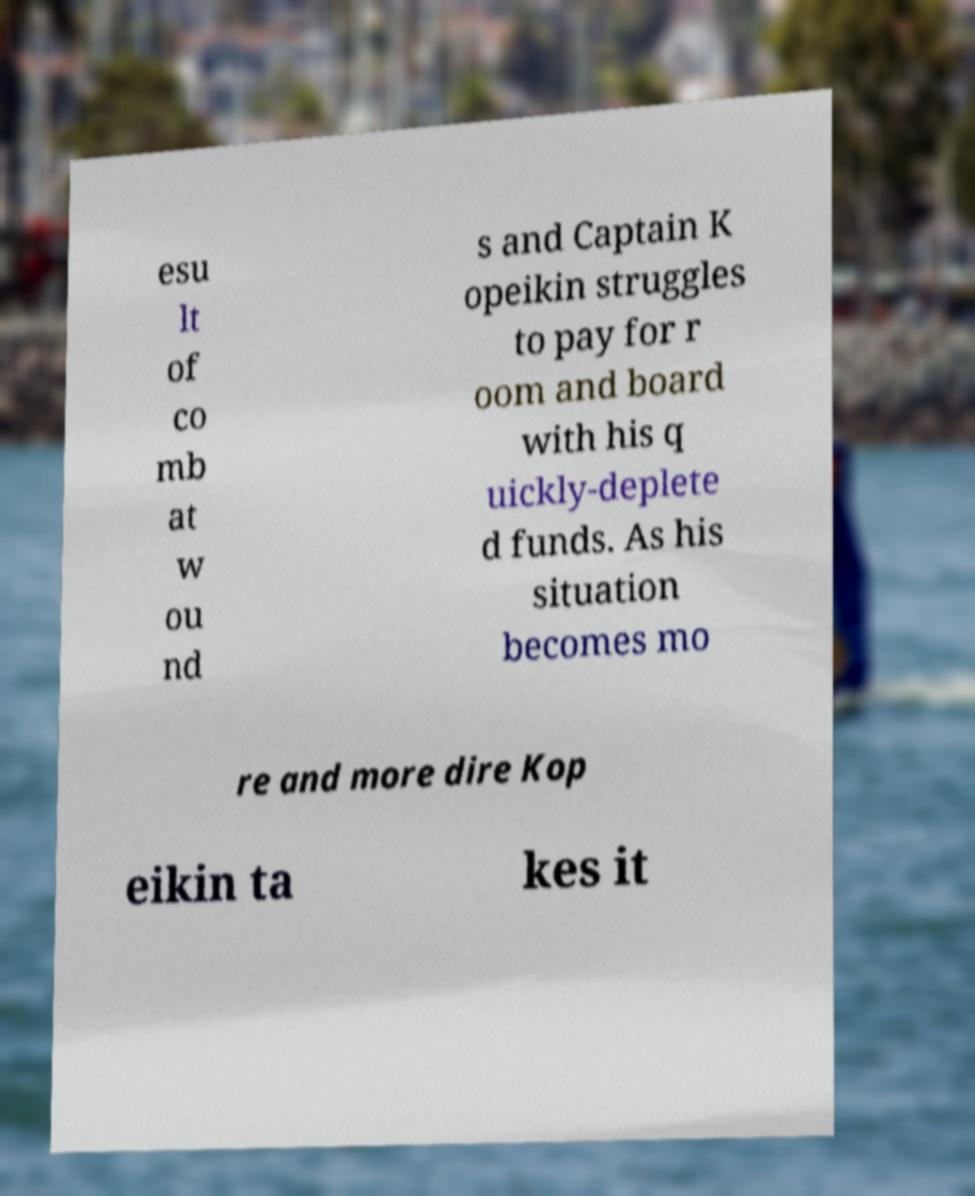What messages or text are displayed in this image? I need them in a readable, typed format. esu lt of co mb at w ou nd s and Captain K opeikin struggles to pay for r oom and board with his q uickly-deplete d funds. As his situation becomes mo re and more dire Kop eikin ta kes it 